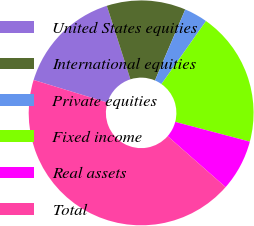Convert chart to OTSL. <chart><loc_0><loc_0><loc_500><loc_500><pie_chart><fcel>United States equities<fcel>International equities<fcel>Private equities<fcel>Fixed income<fcel>Real assets<fcel>Total<nl><fcel>15.34%<fcel>11.35%<fcel>3.37%<fcel>19.33%<fcel>7.36%<fcel>43.25%<nl></chart> 